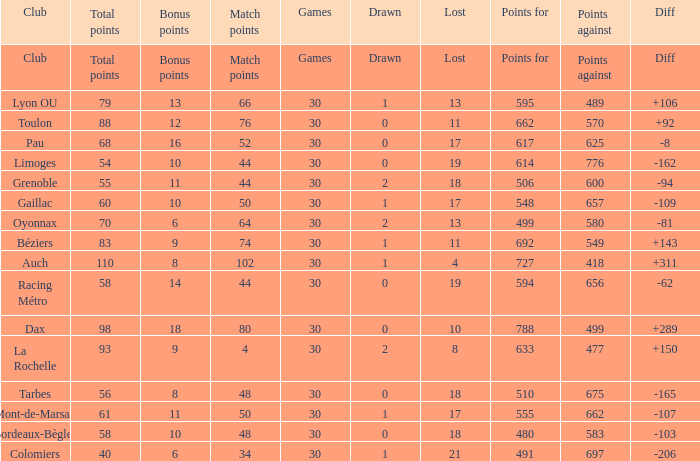I'm looking to parse the entire table for insights. Could you assist me with that? {'header': ['Club', 'Total points', 'Bonus points', 'Match points', 'Games', 'Drawn', 'Lost', 'Points for', 'Points against', 'Diff'], 'rows': [['Club', 'Total points', 'Bonus points', 'Match points', 'Games', 'Drawn', 'Lost', 'Points for', 'Points against', 'Diff'], ['Lyon OU', '79', '13', '66', '30', '1', '13', '595', '489', '+106'], ['Toulon', '88', '12', '76', '30', '0', '11', '662', '570', '+92'], ['Pau', '68', '16', '52', '30', '0', '17', '617', '625', '-8'], ['Limoges', '54', '10', '44', '30', '0', '19', '614', '776', '-162'], ['Grenoble', '55', '11', '44', '30', '2', '18', '506', '600', '-94'], ['Gaillac', '60', '10', '50', '30', '1', '17', '548', '657', '-109'], ['Oyonnax', '70', '6', '64', '30', '2', '13', '499', '580', '-81'], ['Béziers', '83', '9', '74', '30', '1', '11', '692', '549', '+143'], ['Auch', '110', '8', '102', '30', '1', '4', '727', '418', '+311'], ['Racing Métro', '58', '14', '44', '30', '0', '19', '594', '656', '-62'], ['Dax', '98', '18', '80', '30', '0', '10', '788', '499', '+289'], ['La Rochelle', '93', '9', '4', '30', '2', '8', '633', '477', '+150'], ['Tarbes', '56', '8', '48', '30', '0', '18', '510', '675', '-165'], ['Mont-de-Marsan', '61', '11', '50', '30', '1', '17', '555', '662', '-107'], ['Bordeaux-Bègles', '58', '10', '48', '30', '0', '18', '480', '583', '-103'], ['Colomiers', '40', '6', '34', '30', '1', '21', '491', '697', '-206']]} What is the number of games for a club that has 34 match points? 30.0. 